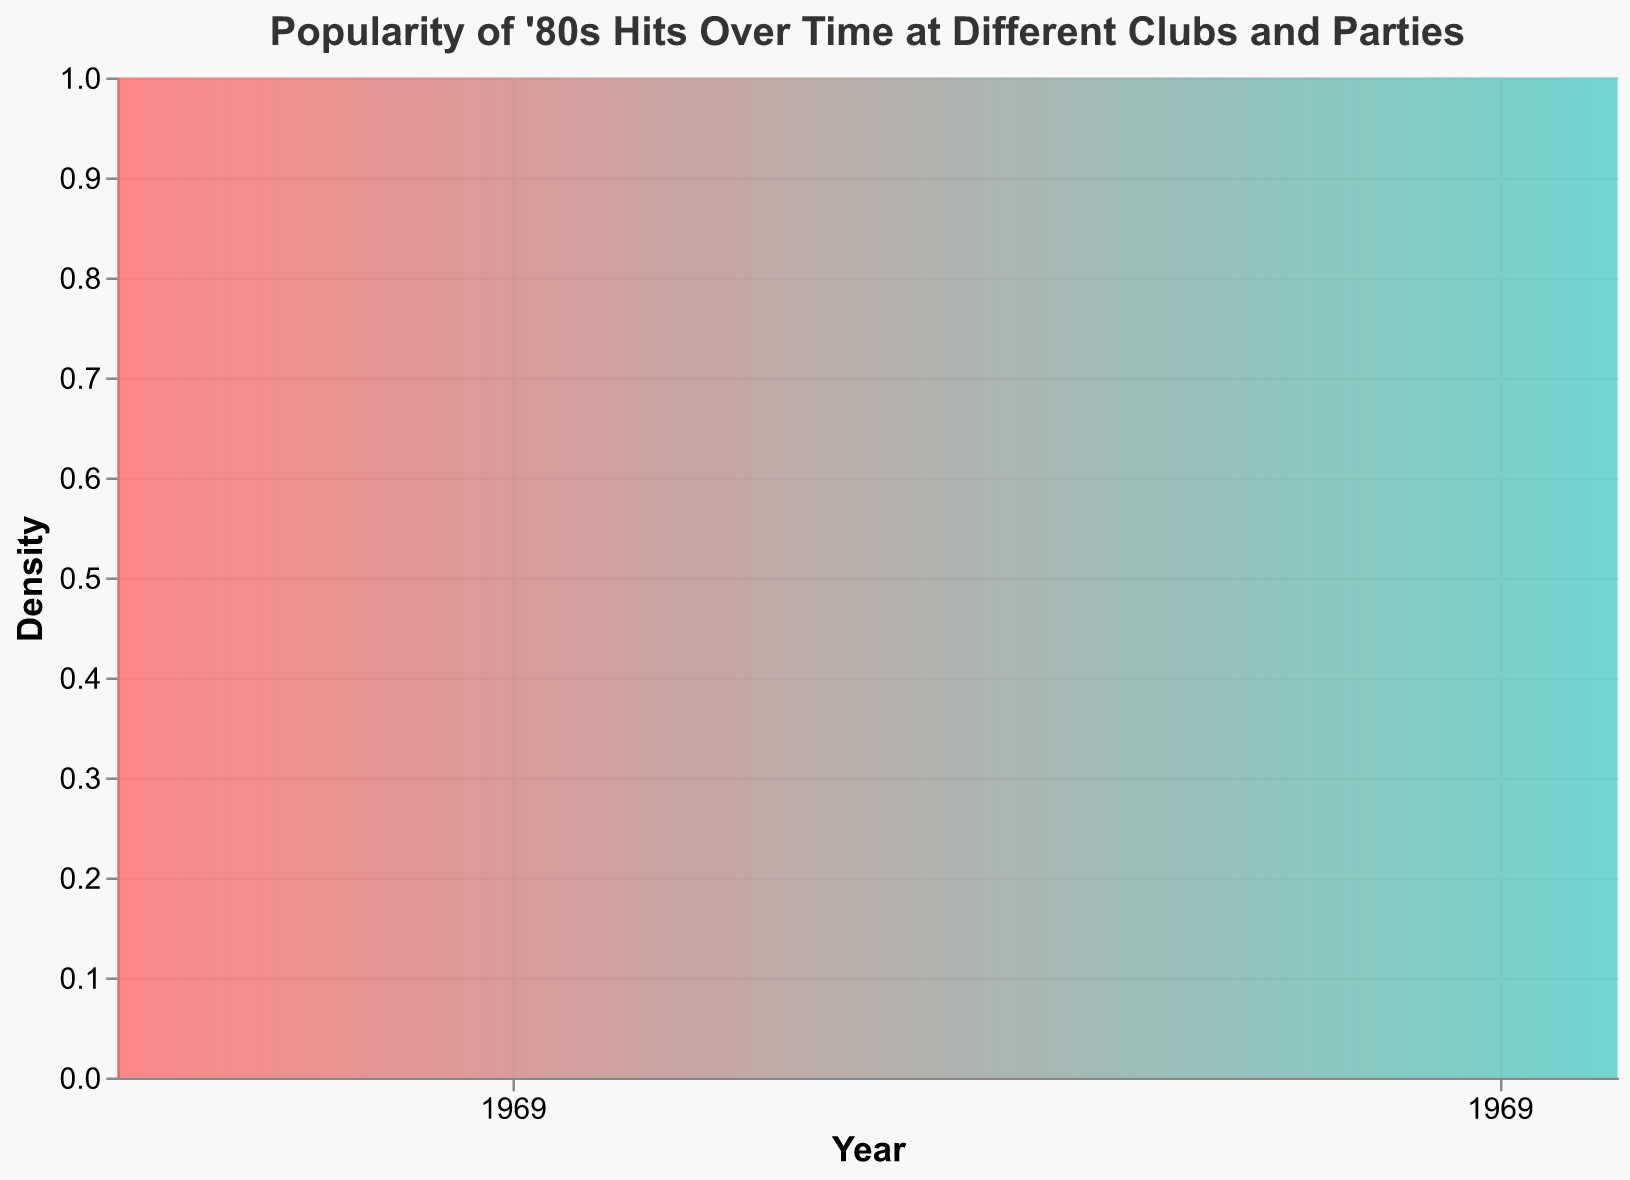What is the highest popularity score recorded in the dataset? The highest popularity score can be identified by looking for the peak points on the density plot.
Answer: 85 Which year(s) saw the highest number of clubs hosting '80s hits events? Check the year on the x-axis where the density is highest. As the density peaks in the range between 1995 and 2000, these years likely have more events.
Answer: 1999 What is the general trend of popularity scores over time? By observing the overall shape of the density plot, we can interpret whether the popularity scores are rising, falling, or fluctuating over time. The density seems to peak in certain periods and then reduce, indicating fluctuations.
Answer: Fluctuating Between which years does the density show the most significant increase? Look for the section of the x-axis where the gradient of the density plot is steepest, indicating a rapid increase in the number of events or interest.
Answer: 1993-1999 Identify a noticeable dip in the density plot and state the years it spans. Find the points on the plot where the density significantly drops and note those years.
Answer: Around 2001-2002 Compare the density of events before and after the year 2000. Observe the general height of the density plot before and after the year 2000. Noticeable differences in density height indicate differences in event frequency.
Answer: Higher before 2000 Which city appears most frequently based on the popularity scores? We need to assess the data for different clubs represented on the plot, but based on historical club fame and popularity, New York is a good candidate to check the frequency of.
Answer: New York What is the smallest interval between years with maximum popularity scores? Locate the years where the popularity score is maximized (peaks in the density plot) and measure the smallest interval between these years.
Answer: 4 years (1986-1990) In what year does the density plot have a significant trough? Identify the year where the density plot shows a distinct low point, indicating a decrease in events or popularity.
Answer: 2001 